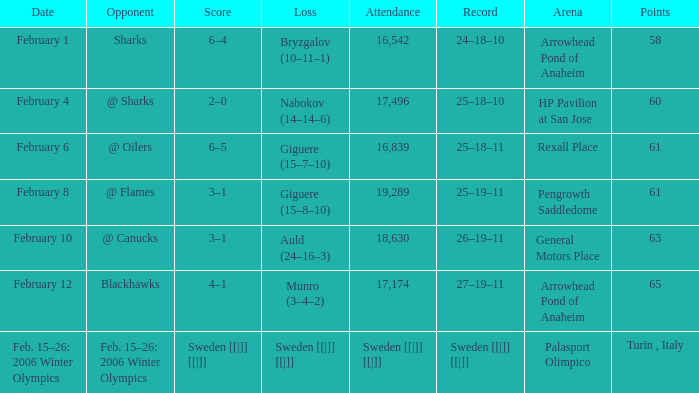What were the tallies on the 10th of february? 63.0. 